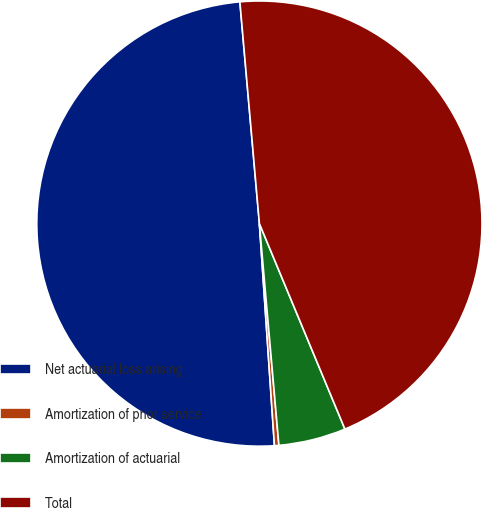<chart> <loc_0><loc_0><loc_500><loc_500><pie_chart><fcel>Net actuarial loss arising<fcel>Amortization of prior service<fcel>Amortization of actuarial<fcel>Total<nl><fcel>49.68%<fcel>0.32%<fcel>4.88%<fcel>45.12%<nl></chart> 